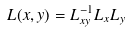<formula> <loc_0><loc_0><loc_500><loc_500>L ( x , y ) = L _ { x y } ^ { - 1 } L _ { x } L _ { y }</formula> 